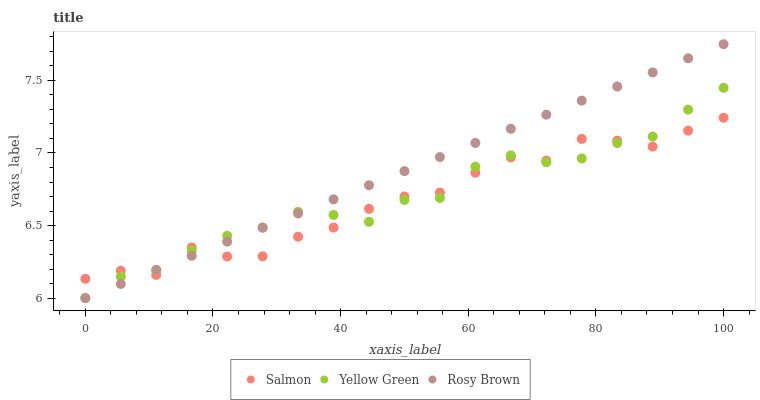Does Salmon have the minimum area under the curve?
Answer yes or no. Yes. Does Rosy Brown have the maximum area under the curve?
Answer yes or no. Yes. Does Yellow Green have the minimum area under the curve?
Answer yes or no. No. Does Yellow Green have the maximum area under the curve?
Answer yes or no. No. Is Rosy Brown the smoothest?
Answer yes or no. Yes. Is Salmon the roughest?
Answer yes or no. Yes. Is Yellow Green the smoothest?
Answer yes or no. No. Is Yellow Green the roughest?
Answer yes or no. No. Does Rosy Brown have the lowest value?
Answer yes or no. Yes. Does Salmon have the lowest value?
Answer yes or no. No. Does Rosy Brown have the highest value?
Answer yes or no. Yes. Does Yellow Green have the highest value?
Answer yes or no. No. Does Rosy Brown intersect Salmon?
Answer yes or no. Yes. Is Rosy Brown less than Salmon?
Answer yes or no. No. Is Rosy Brown greater than Salmon?
Answer yes or no. No. 